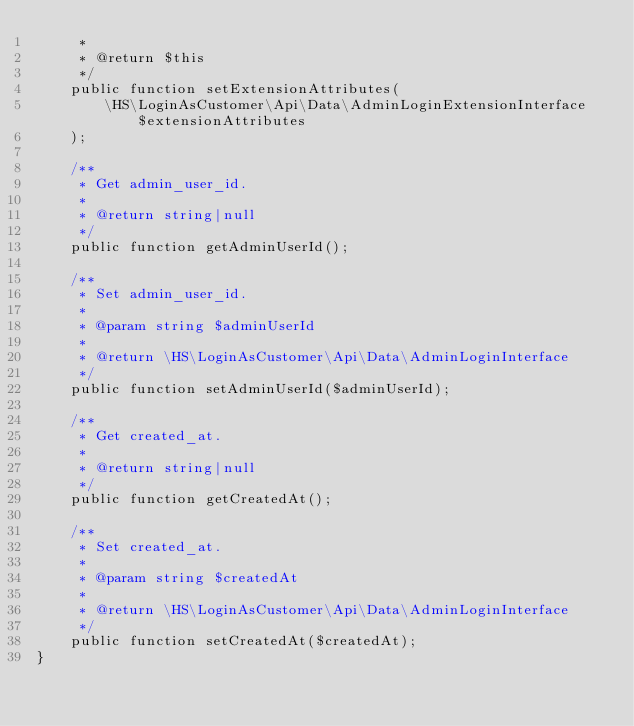Convert code to text. <code><loc_0><loc_0><loc_500><loc_500><_PHP_>     *
     * @return $this
     */
    public function setExtensionAttributes(
        \HS\LoginAsCustomer\Api\Data\AdminLoginExtensionInterface $extensionAttributes
    );

    /**
     * Get admin_user_id.
     *
     * @return string|null
     */
    public function getAdminUserId();

    /**
     * Set admin_user_id.
     *
     * @param string $adminUserId
     *
     * @return \HS\LoginAsCustomer\Api\Data\AdminLoginInterface
     */
    public function setAdminUserId($adminUserId);

    /**
     * Get created_at.
     *
     * @return string|null
     */
    public function getCreatedAt();

    /**
     * Set created_at.
     *
     * @param string $createdAt
     *
     * @return \HS\LoginAsCustomer\Api\Data\AdminLoginInterface
     */
    public function setCreatedAt($createdAt);
}
</code> 